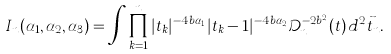<formula> <loc_0><loc_0><loc_500><loc_500>I _ { n } ( \alpha _ { 1 } , \alpha _ { 2 } , \alpha _ { 3 } ) = \int \prod _ { k = 1 } ^ { n } | t _ { k } | ^ { - 4 b \alpha _ { 1 } } | t _ { k } - 1 | ^ { - 4 b \alpha _ { 2 } } \mathcal { D } ^ { - 2 b ^ { 2 } } _ { n } ( t ) \, d ^ { 2 } \vec { t } _ { n } .</formula> 